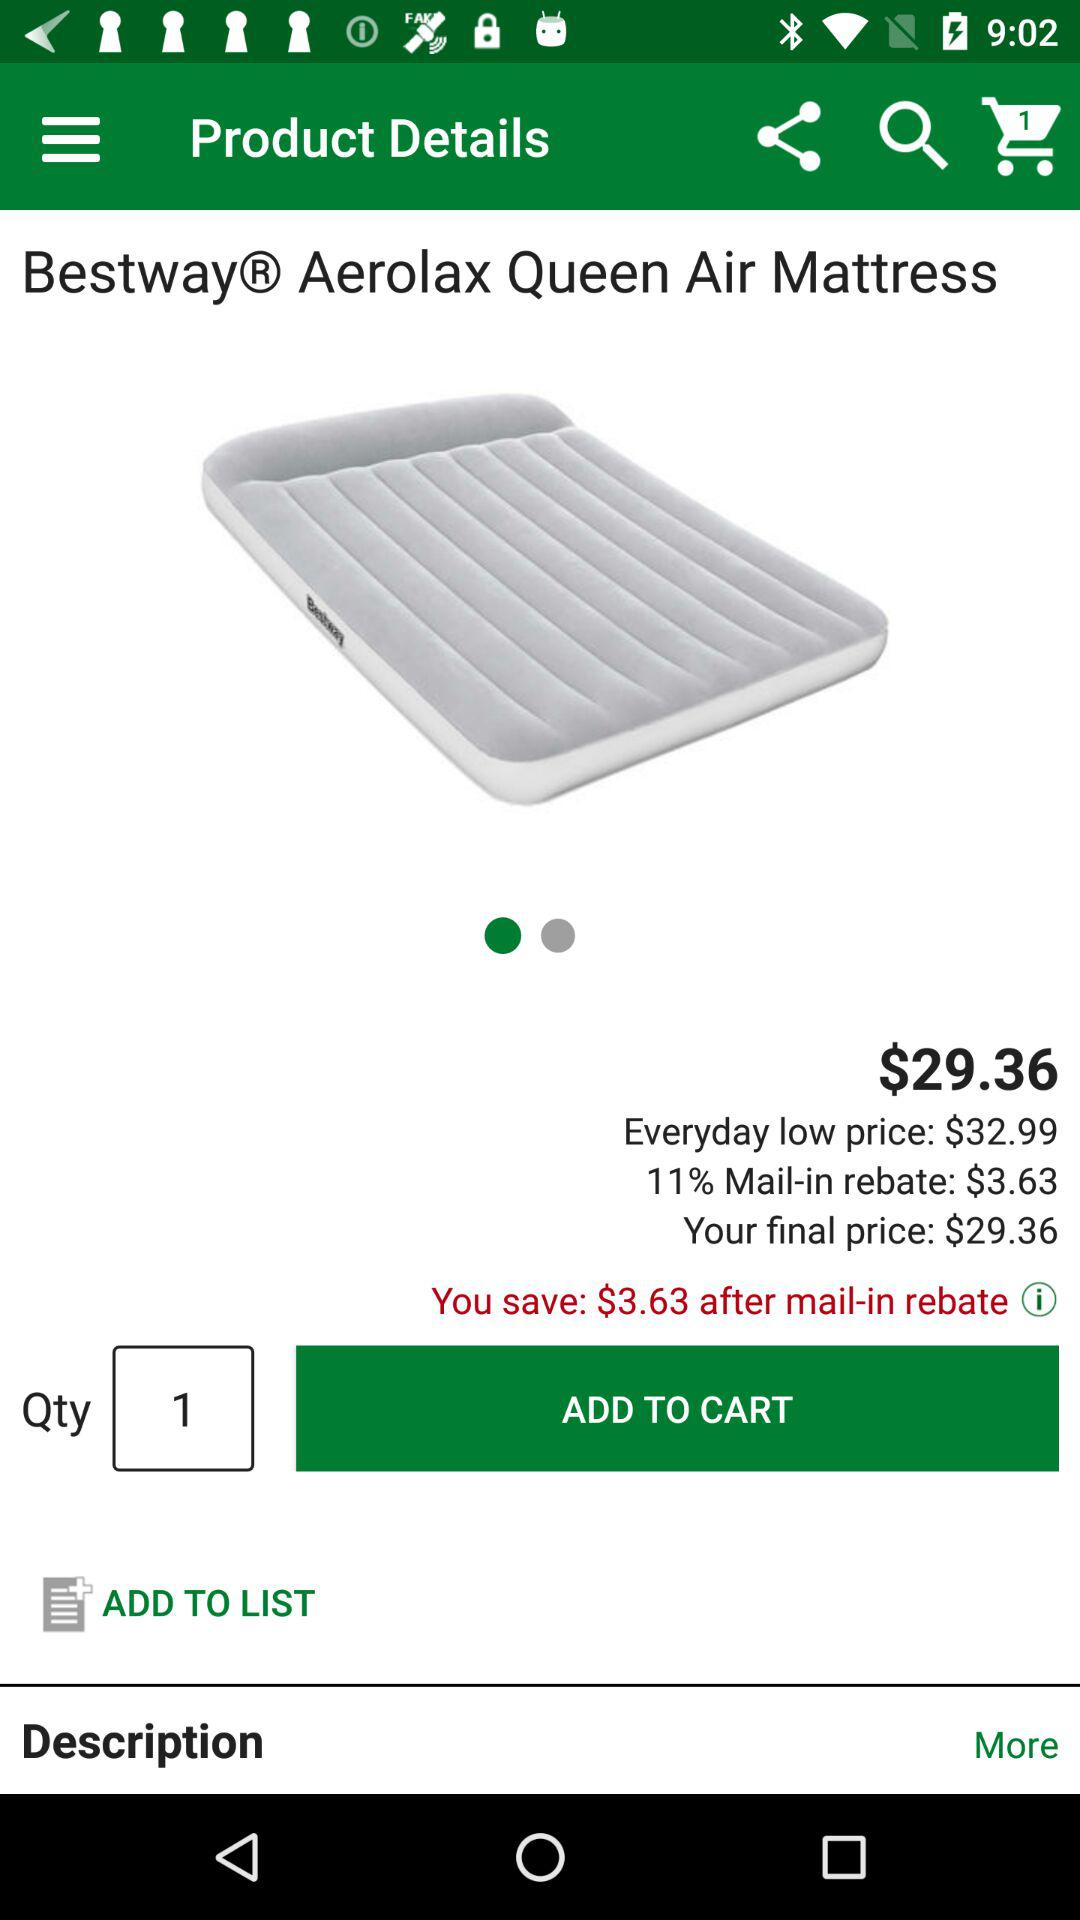What is the name of the product shown? The name of the product is "Bestway Aerolax Queen Air Mattress". 